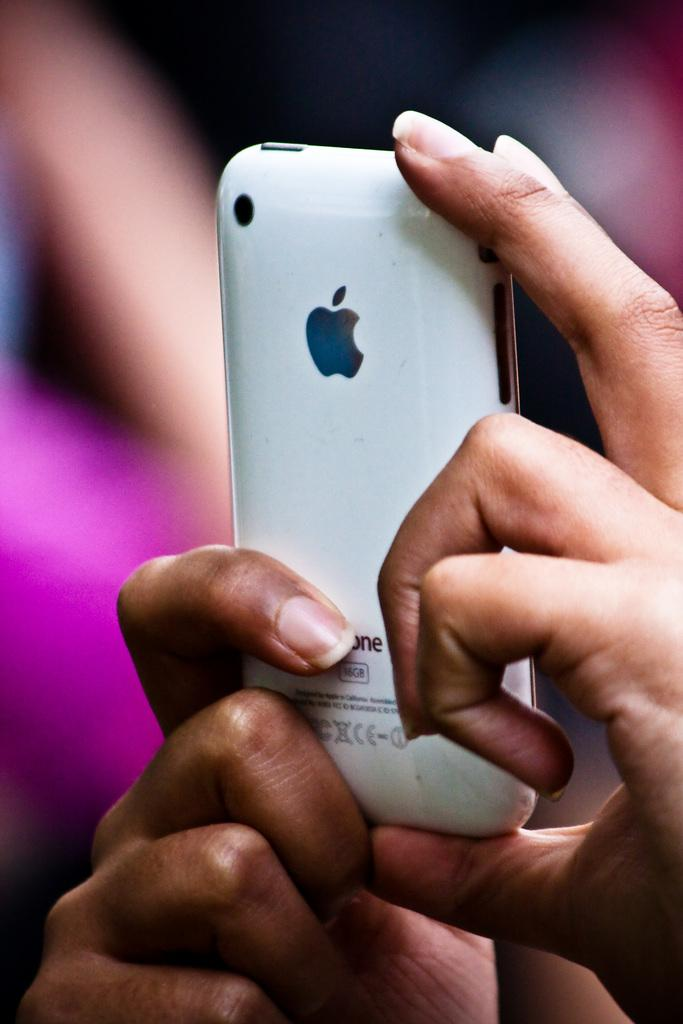What is the main subject of the image? The main subject of the image is a person's hand. What is the hand holding in the image? The hand is holding a mobile in the image. Where is the hand and mobile located in the image? The hand and mobile are in the center of the image. What type of cherries are hanging from the net in the image? There is no net or cherries present in the image; it only features a person's hand holding a mobile. 